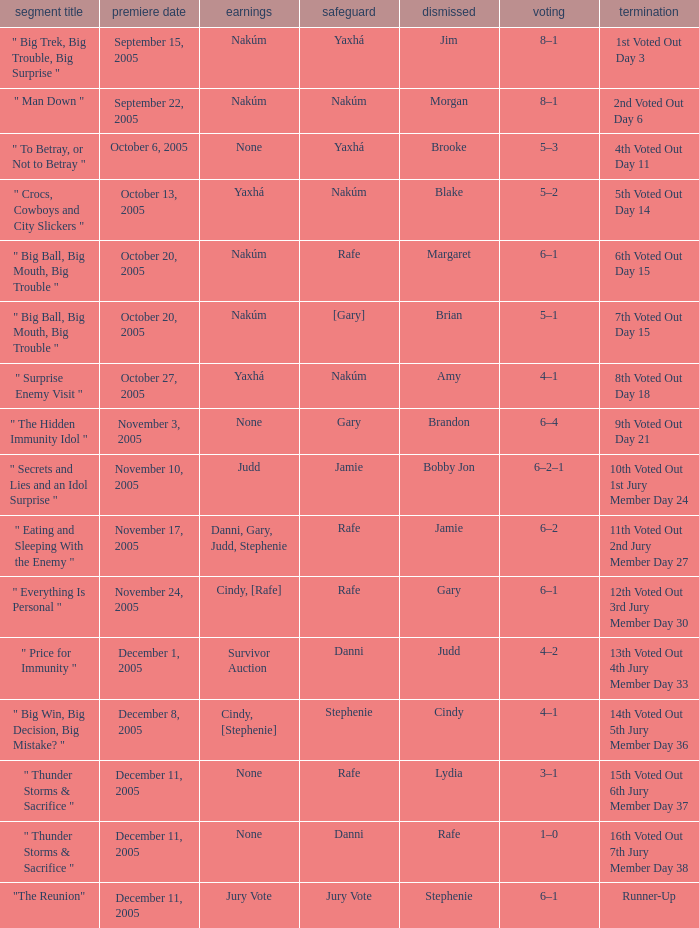When jim is eliminated what is the finish? 1st Voted Out Day 3. 